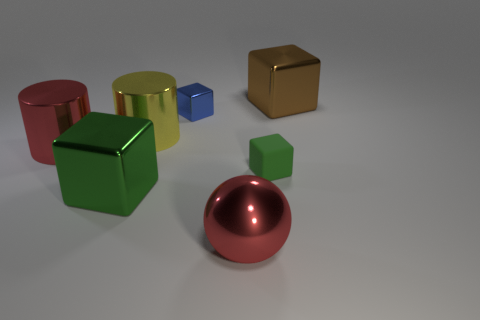How many other things are the same color as the small metal block?
Your response must be concise. 0. Is the number of metallic things greater than the number of large green objects?
Make the answer very short. Yes. What is the big green block made of?
Your answer should be compact. Metal. There is a object right of the matte thing; does it have the same size as the small blue block?
Your answer should be compact. No. How big is the shiny cube that is on the left side of the blue metal object?
Offer a very short reply. Large. Is there any other thing that is the same material as the blue object?
Your answer should be very brief. Yes. How many big red metal cylinders are there?
Provide a succinct answer. 1. Do the shiny sphere and the matte thing have the same color?
Ensure brevity in your answer.  No. What is the color of the block that is both in front of the small blue block and behind the large green cube?
Give a very brief answer. Green. There is a tiny blue shiny cube; are there any metal things behind it?
Provide a short and direct response. Yes. 